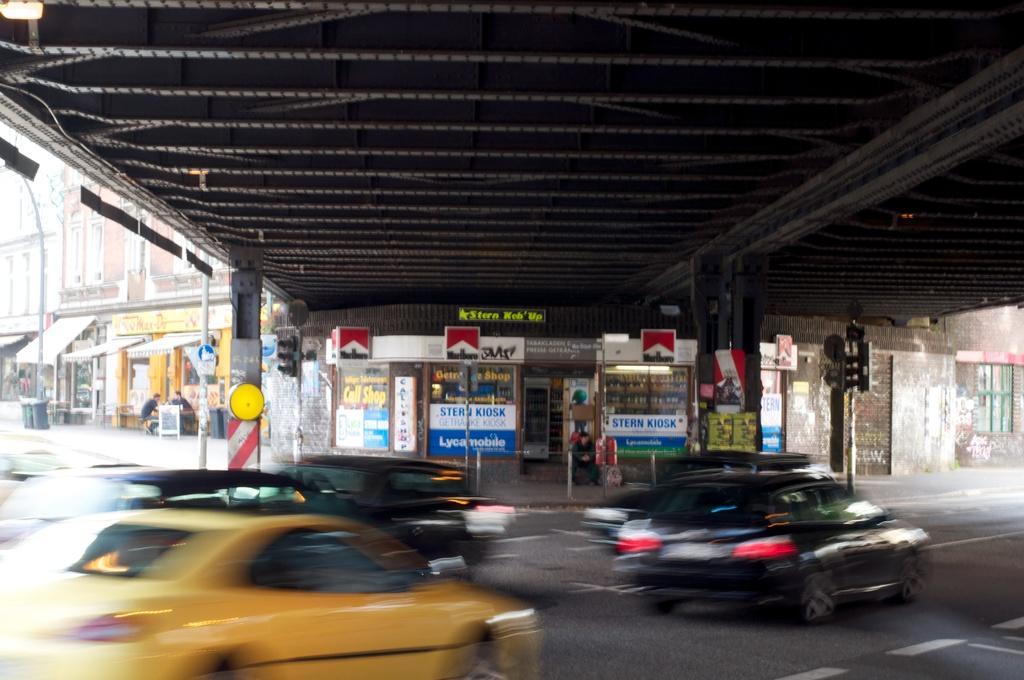Can you describe this image briefly? In this image I can see a road in the front and on it I can see number of cars. In the background I can see few poles, few sign boards, number of stores, number of boards and on these boards I can see something is written. 